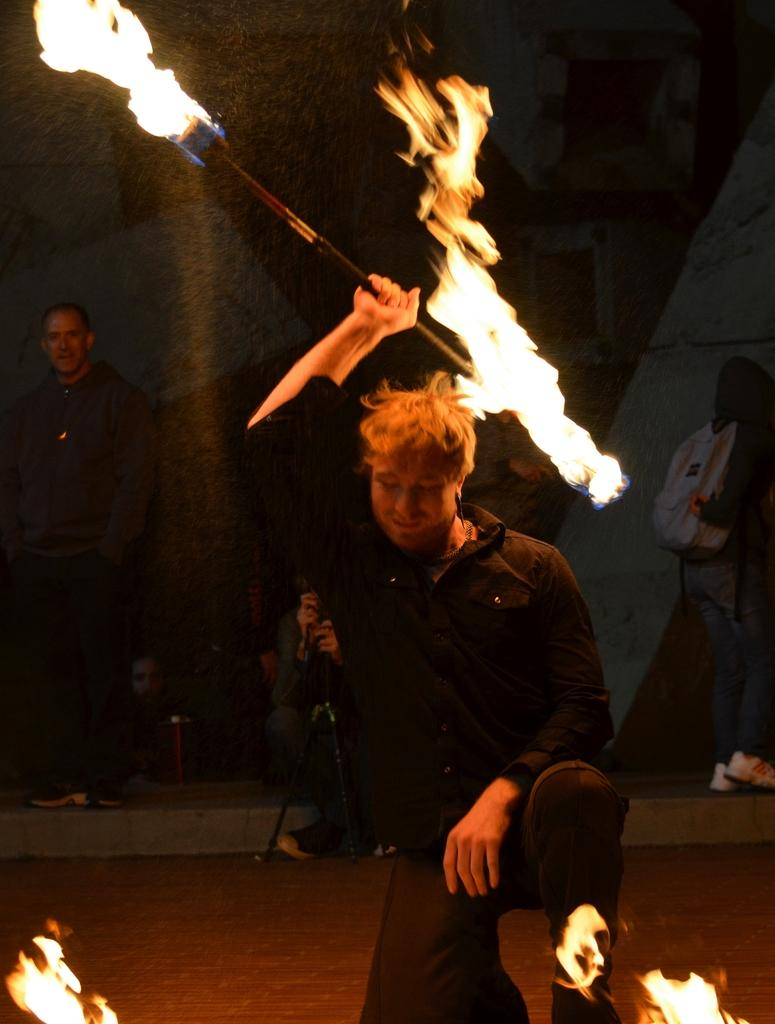What is the person in the foreground of the image doing? The person is playing with fire in the image. Can you describe the people in the background of the image? There are people in the background of the image, but their specific actions or appearances are not mentioned in the provided facts. What else can be seen in the background of the image? There are some objects in the background of the image, but their specific nature is not mentioned in the provided facts. What type of shirt is the person wearing while playing with hands in the image? There is no mention of a shirt or hands in the image; the person is playing with fire. What kind of support is the person using to play with fire in the image? The provided facts do not mention any specific support being used by the person playing with fire in the image. 